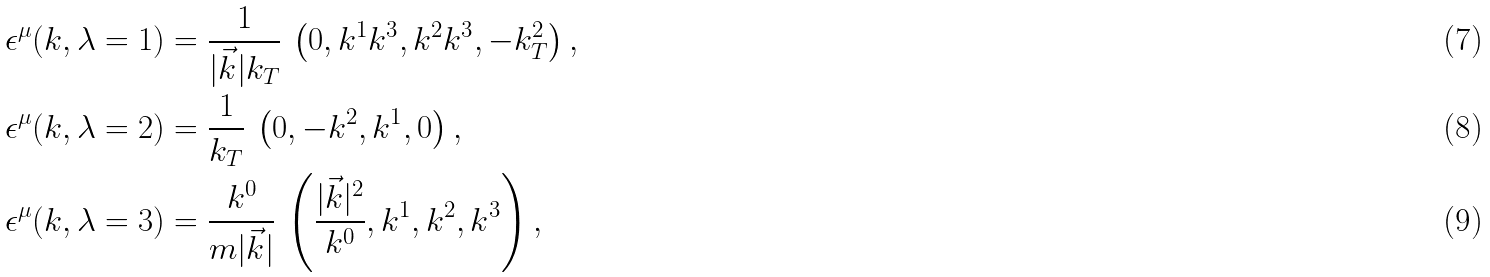<formula> <loc_0><loc_0><loc_500><loc_500>\epsilon ^ { \mu } ( k , \lambda = 1 ) & = \frac { 1 } { | \vec { k } | k _ { T } } \, \left ( 0 , k ^ { 1 } k ^ { 3 } , k ^ { 2 } k ^ { 3 } , - k _ { T } ^ { 2 } \right ) , \\ \epsilon ^ { \mu } ( k , \lambda = 2 ) & = \frac { 1 } { k _ { T } } \, \left ( 0 , - k ^ { 2 } , k ^ { 1 } , 0 \right ) , \\ \epsilon ^ { \mu } ( k , \lambda = 3 ) & = \frac { k ^ { 0 } } { m | \vec { k } | } \, \left ( \frac { | \vec { k } | ^ { 2 } } { k ^ { 0 } } , k ^ { 1 } , k ^ { 2 } , k ^ { 3 } \right ) ,</formula> 